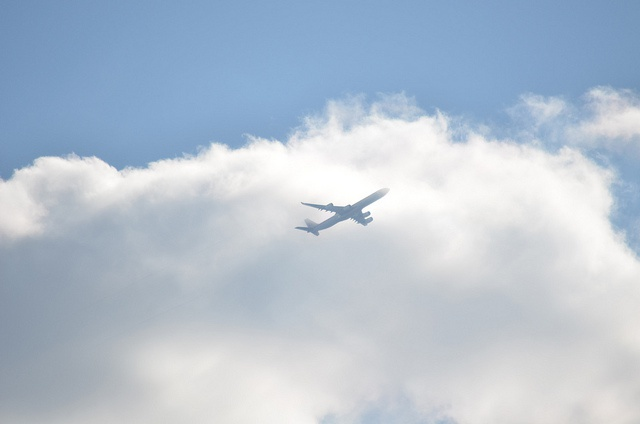Describe the objects in this image and their specific colors. I can see a airplane in gray, darkgray, and lightgray tones in this image. 